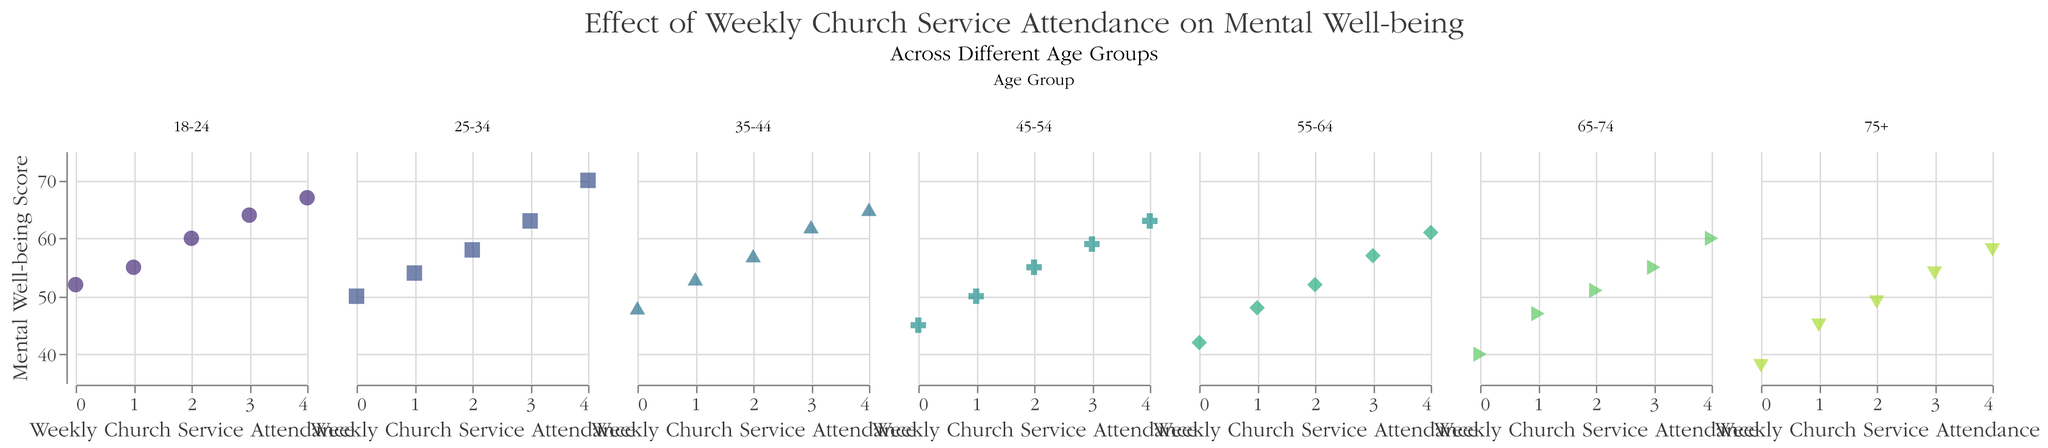What is the title of the figure? The title of the figure is displayed at the top and reads "Effect of Weekly Church Service Attendance on Mental Well-being".
Answer: Effect of Weekly Church Service Attendance on Mental Well-being How does the mental well-being score change for age group 18-24 as weekly church service attendance increases? By observing the scatter plot for age group 18-24, as weekly church service attendance increases from 0 to 4, the mental well-being score increases from 52 to 67.
Answer: It increases Which age group shows the highest mental well-being score with weekly church service attendance of 4? By looking at the scatter plot, the age group 25-34 shows the highest mental well-being score of 70 when the weekly church service attendance is 4.
Answer: 25-34 In the age group 65-74, how does the mental well-being score at attendance level 3 compare to attendance level 0? The mental well-being score for age group 65-74 is 55 at attendance level 3 and 40 at attendance level 0, so it increased by 15 points.
Answer: Increases by 15 points What is the trend in mental well-being scores with increasing church service attendance for the age group 55-64? For the age group 55-64, the mental well-being score continuously increases as the weekly church service attendance increases. The scores are 42, 48, 52, 57, and 61 for attendance levels 0 to 4, respectively.
Answer: Increases continuously Which age group shows the lowest mental well-being score at attendance level 0? By observing the scatter plots, the age group 75+ shows the lowest mental well-being score of 38 at weekly church service attendance level 0.
Answer: 75+ Comparing age groups 25-34 and 35-44, which one shows a greater increase in mental well-being score from attendance level 0 to 4? The mental well-being score for age group 25-34 increases from 50 to 70 (a 20 point increase), while for age group 35-44 it increases from 48 to 65 (a 17 point increase). So, age group 25-34 shows a greater increase.
Answer: 25-34 What is the range of mental well-being scores for the age group 45-54? For age group 45-54, the mental well-being scores range from 45 (at attendance level 0) to 63 (at attendance level 4). The range is the difference between the highest and lowest score, which is 63 - 45 = 18.
Answer: 18 At which attendance level does the age group 35-44 reach a mental well-being score of 62? In the scatter plot, age group 35-44 reaches a mental well-being score of 62 at a weekly church service attendance level of 3.
Answer: 3 